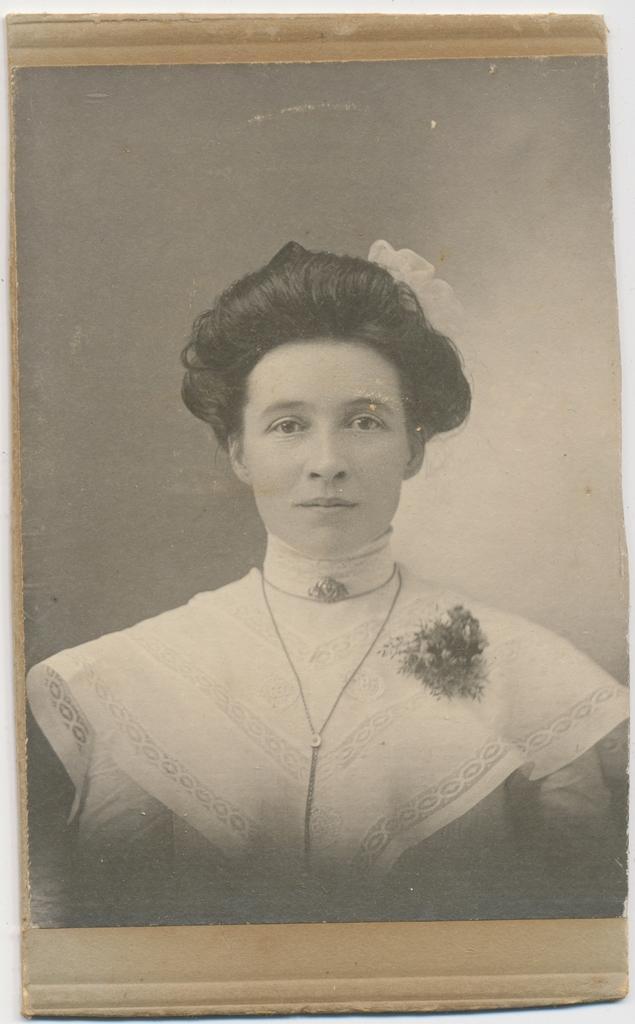How would you summarize this image in a sentence or two? In this image we can see a photo frame of a woman. 